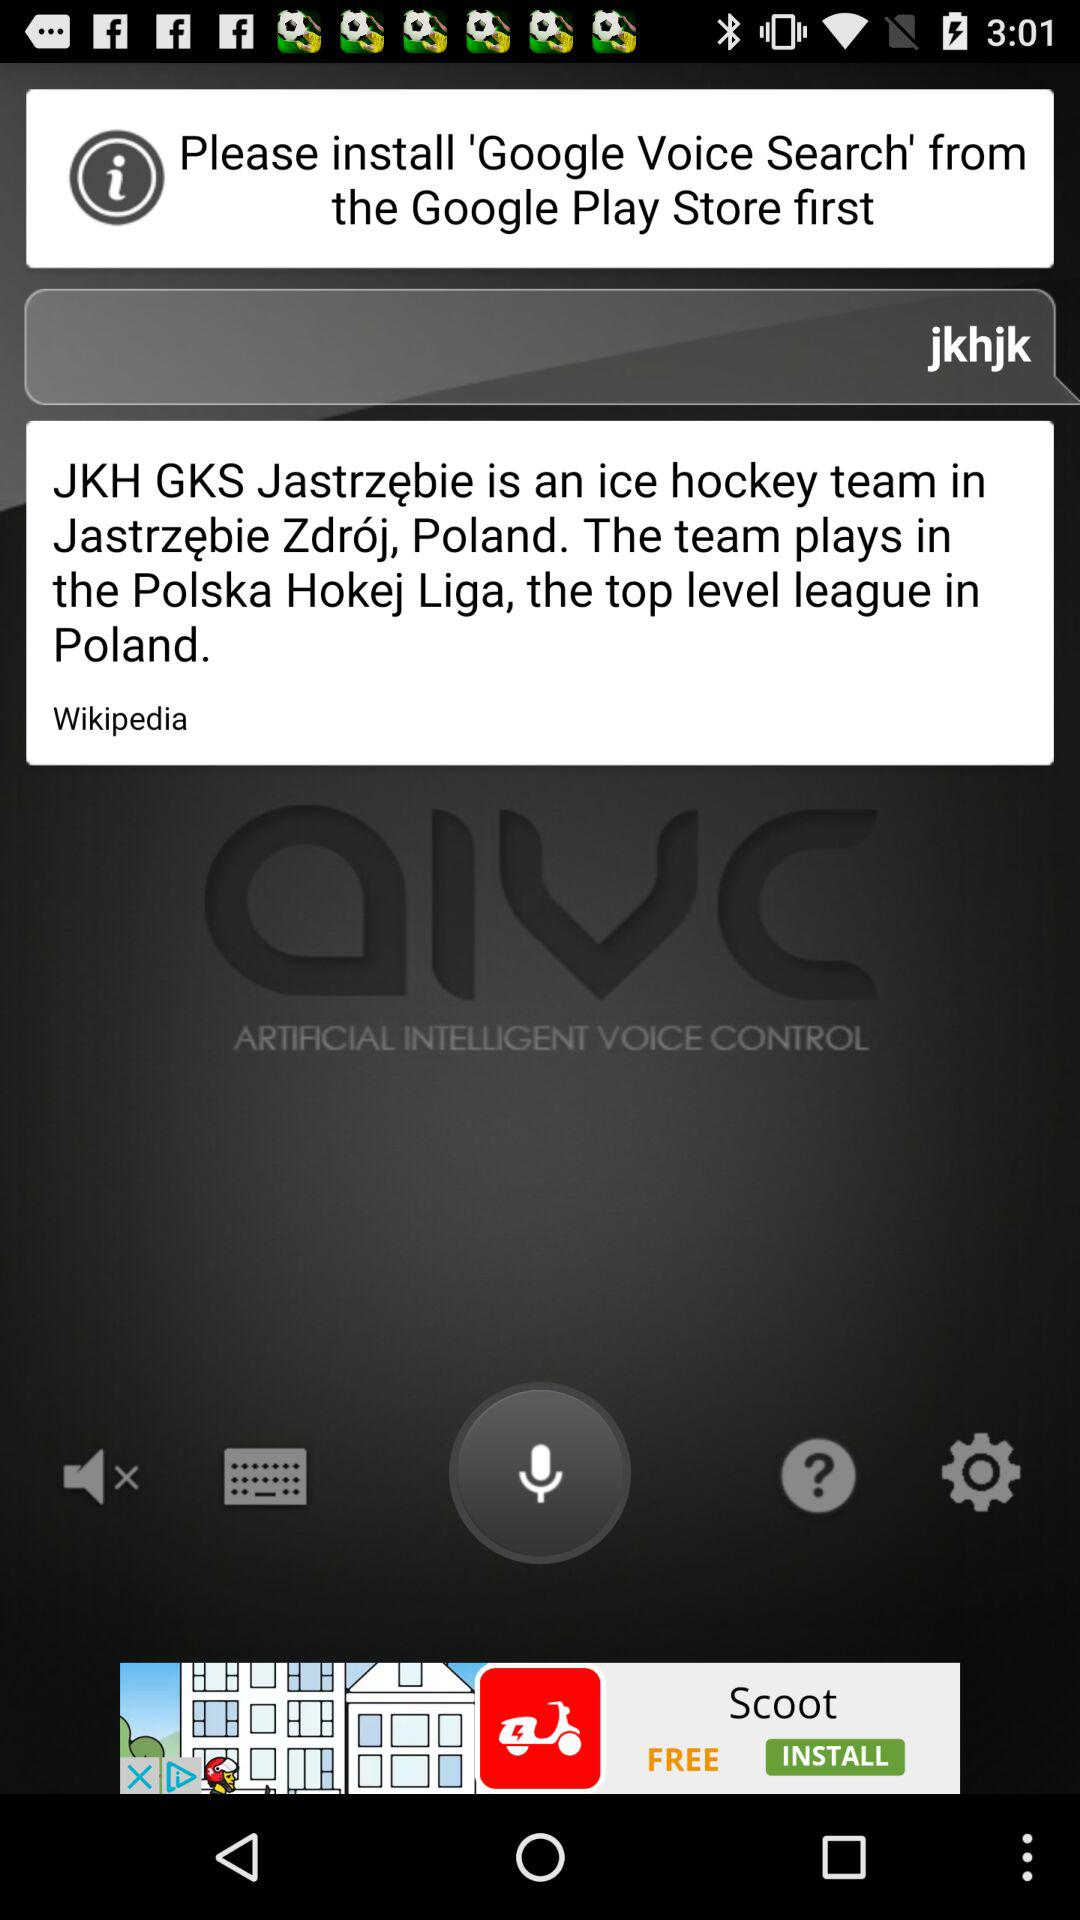What do you need to install first from the Google Play store? You need to first install "Google Voice Search" from the Google Play store. 